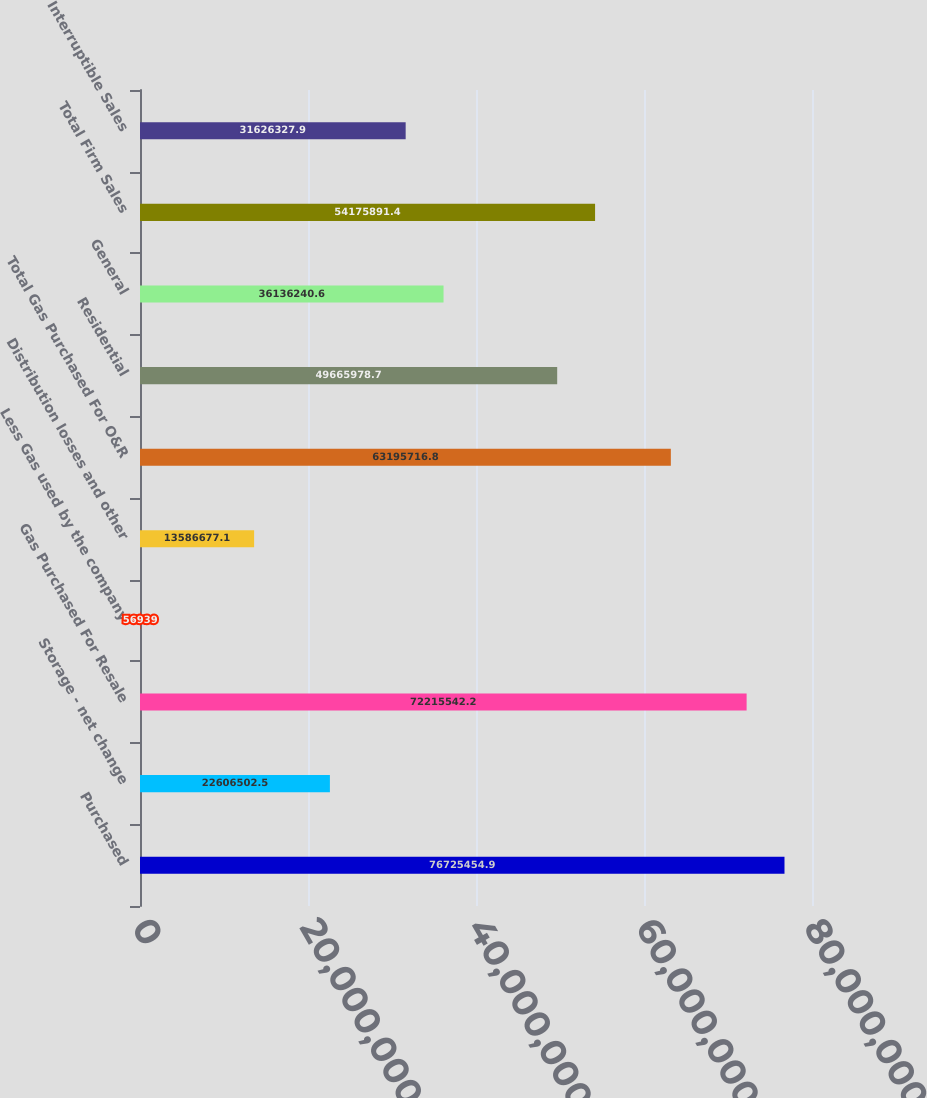Convert chart. <chart><loc_0><loc_0><loc_500><loc_500><bar_chart><fcel>Purchased<fcel>Storage - net change<fcel>Gas Purchased For Resale<fcel>Less Gas used by the company<fcel>Distribution losses and other<fcel>Total Gas Purchased For O&R<fcel>Residential<fcel>General<fcel>Total Firm Sales<fcel>Interruptible Sales<nl><fcel>7.67255e+07<fcel>2.26065e+07<fcel>7.22155e+07<fcel>56939<fcel>1.35867e+07<fcel>6.31957e+07<fcel>4.9666e+07<fcel>3.61362e+07<fcel>5.41759e+07<fcel>3.16263e+07<nl></chart> 